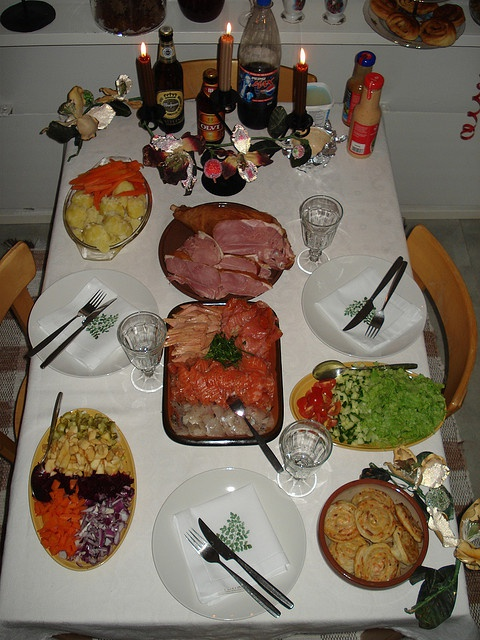Describe the objects in this image and their specific colors. I can see dining table in black, darkgray, and gray tones, bowl in black, olive, and maroon tones, bowl in black, olive, and maroon tones, bowl in black, olive, and maroon tones, and chair in black, maroon, and brown tones in this image. 